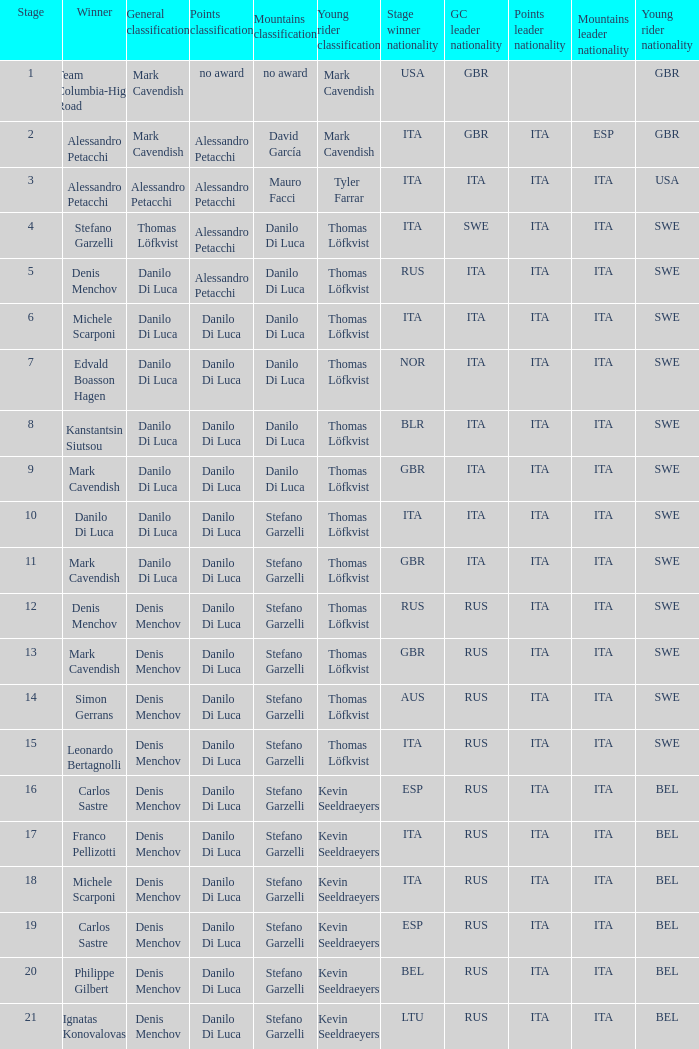When  thomas löfkvist is the general classification who is the winner? Stefano Garzelli. 